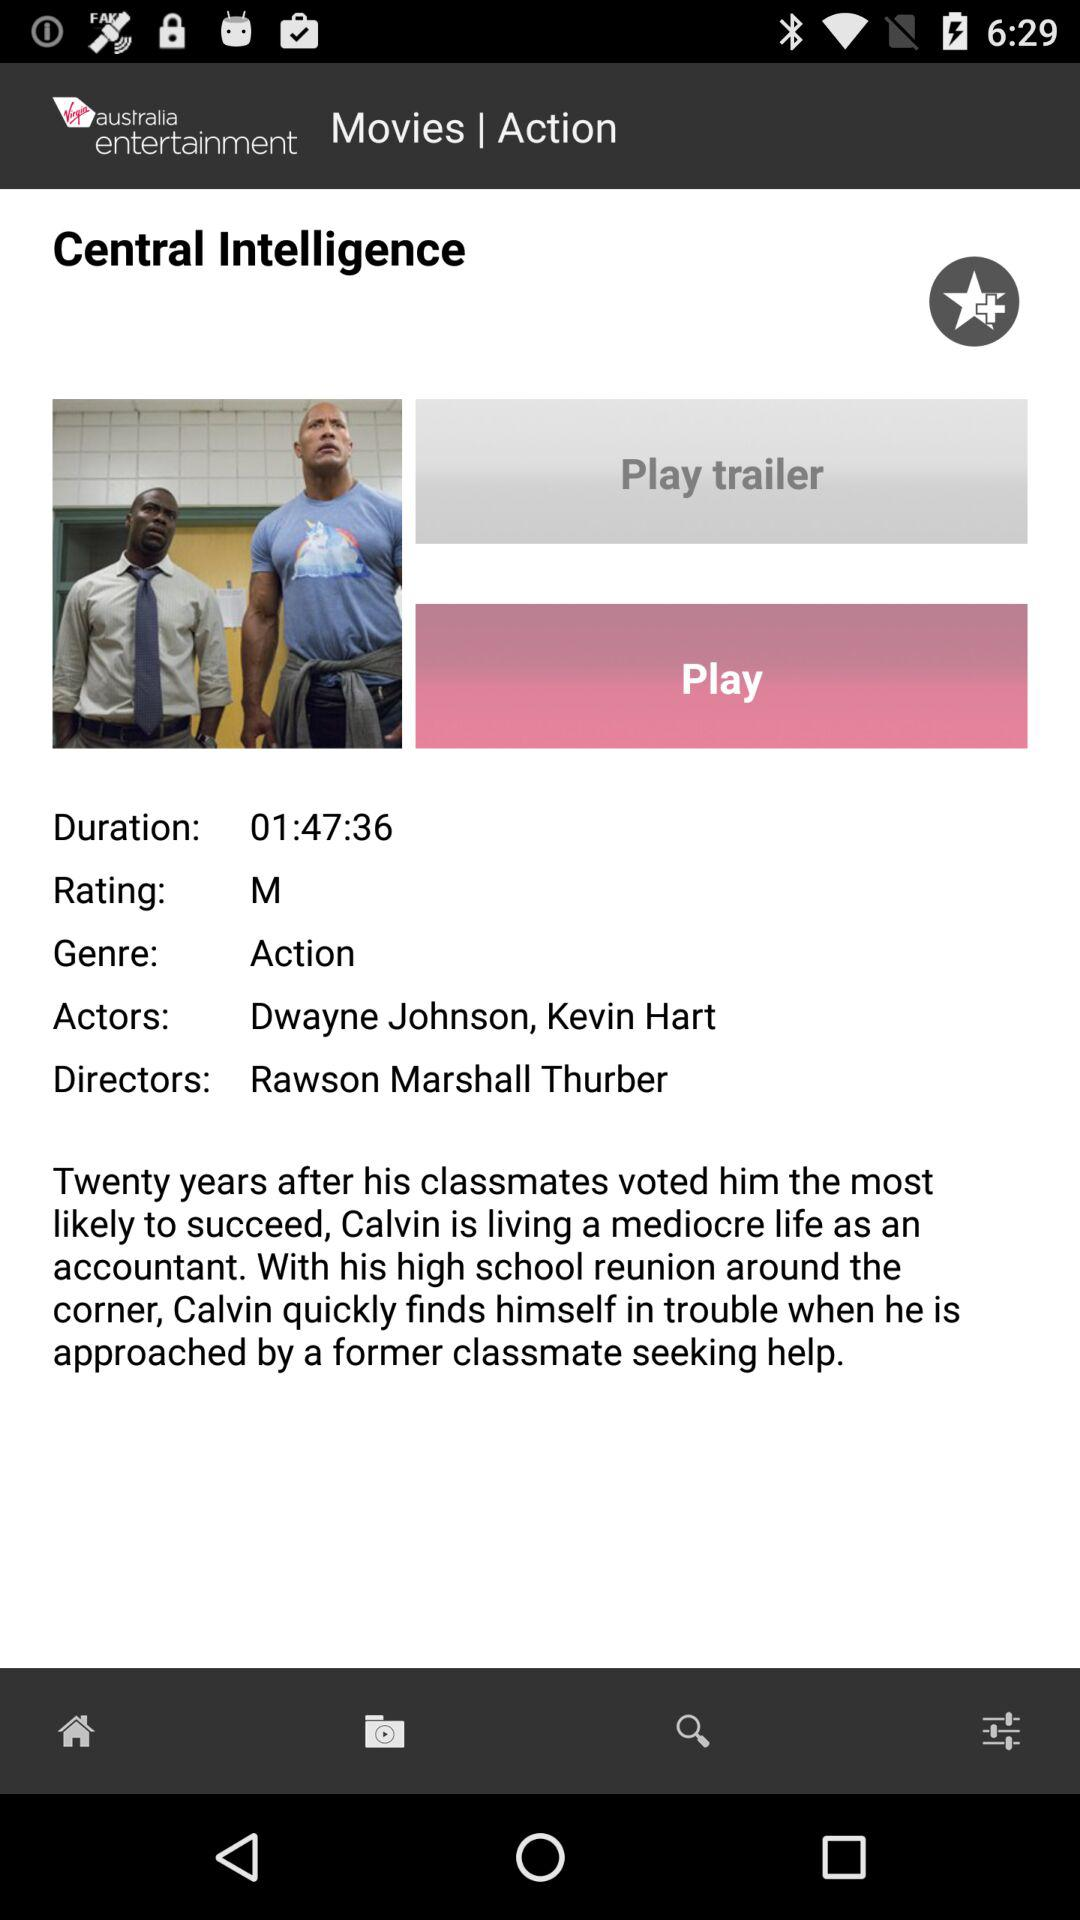When was the movie released?
When the provided information is insufficient, respond with <no answer>. <no answer> 